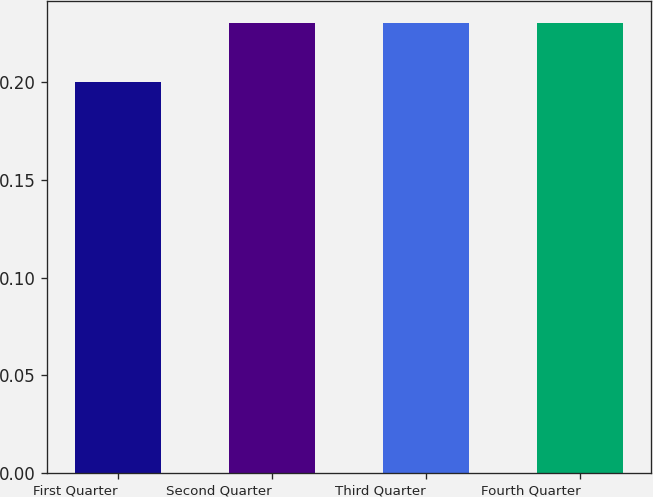Convert chart to OTSL. <chart><loc_0><loc_0><loc_500><loc_500><bar_chart><fcel>First Quarter<fcel>Second Quarter<fcel>Third Quarter<fcel>Fourth Quarter<nl><fcel>0.2<fcel>0.23<fcel>0.23<fcel>0.23<nl></chart> 